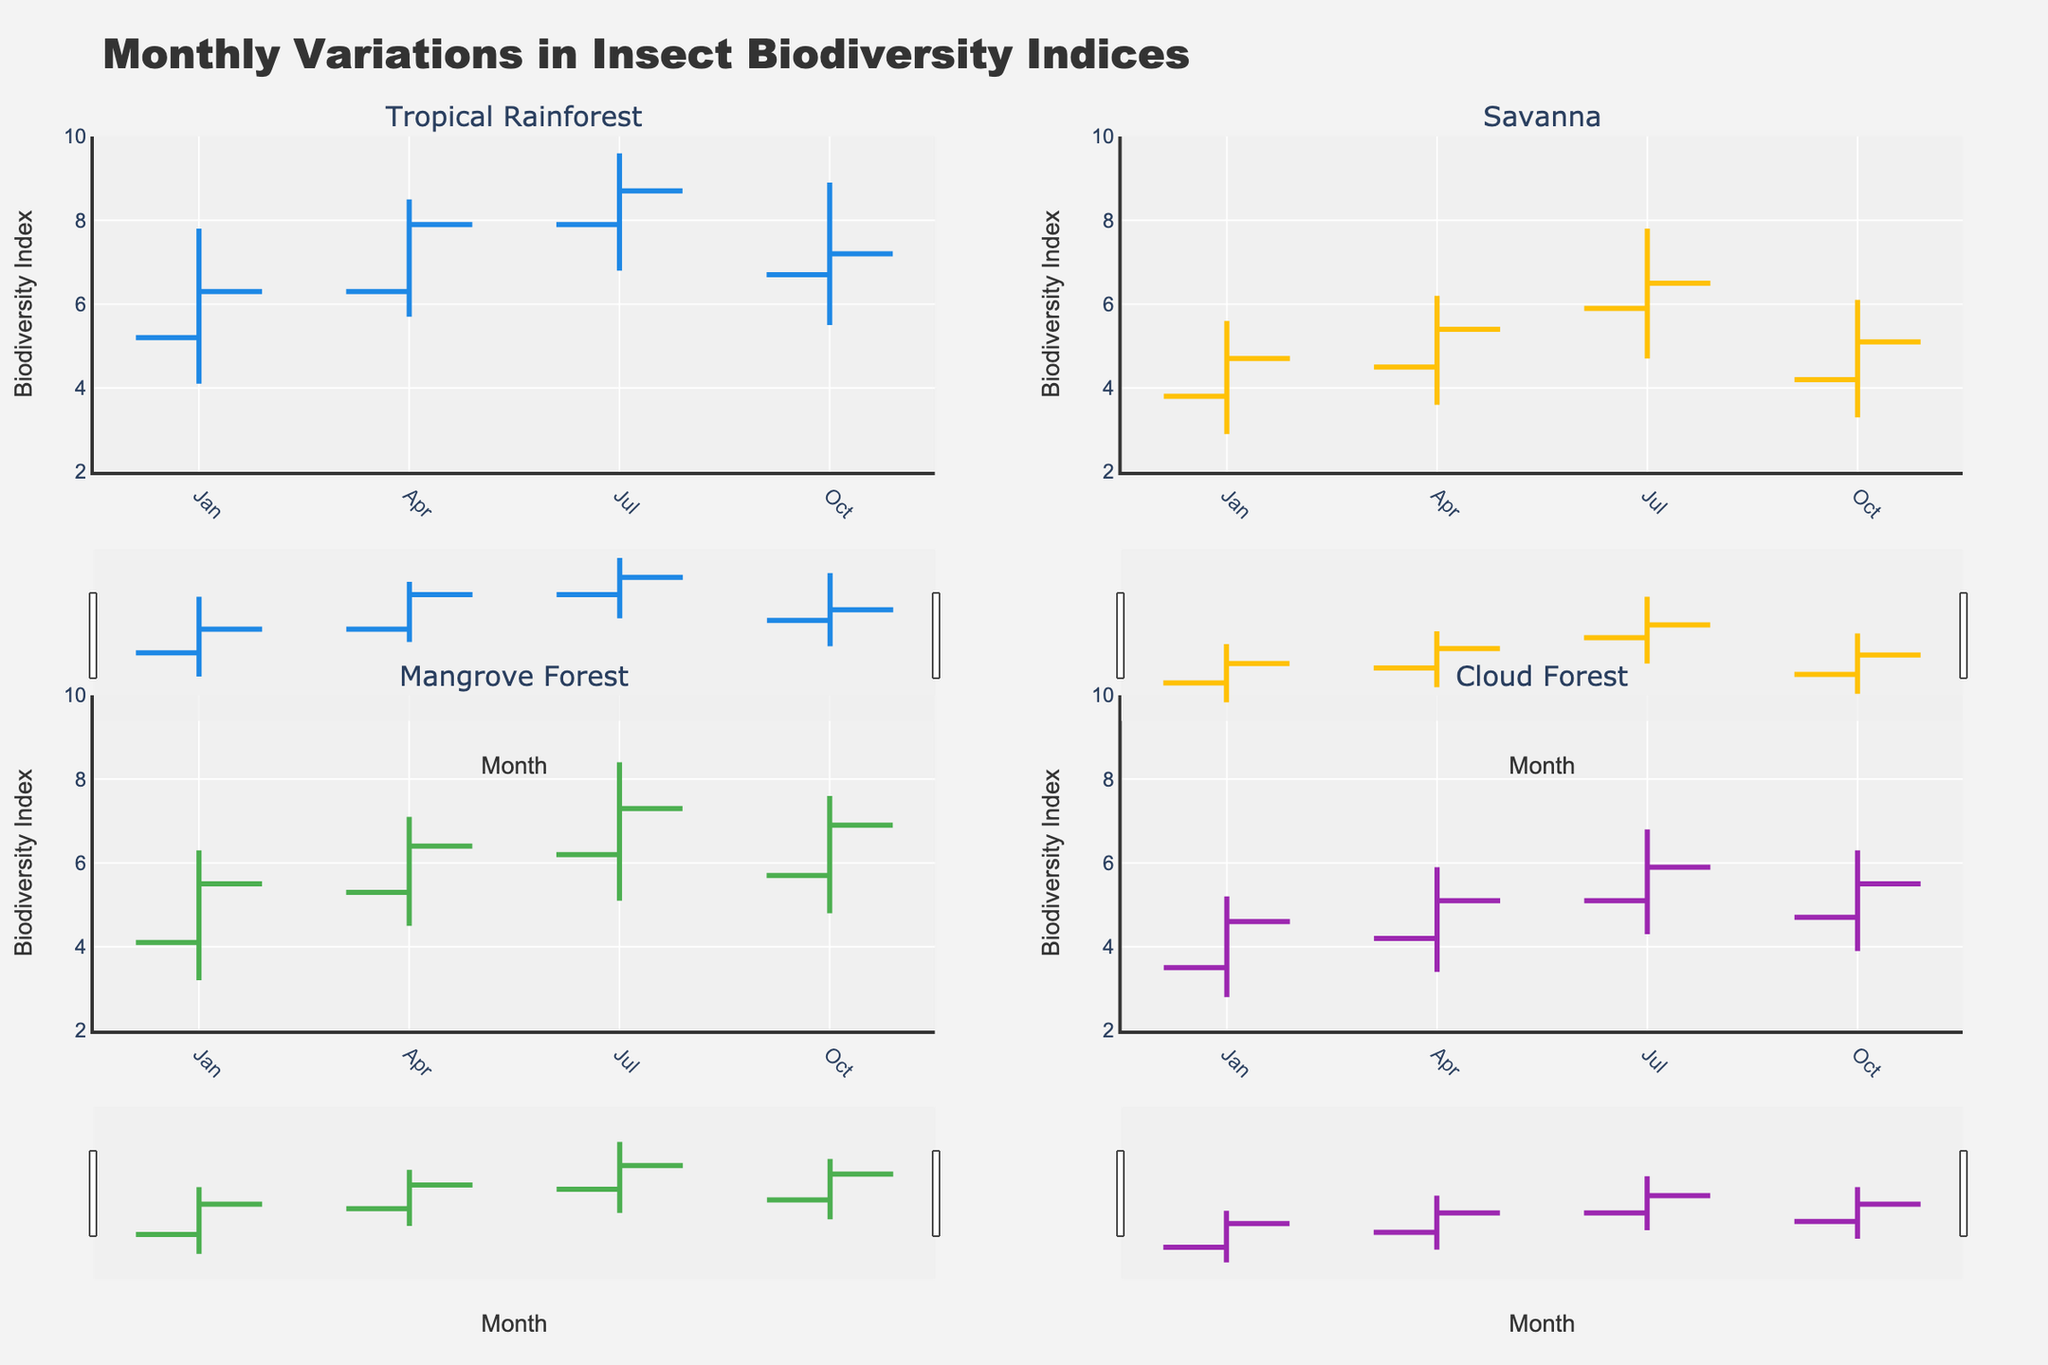Which ecosystem has the highest observed biodiversity index in July? We look at the 'High' values for July in each ecosystem. The highest 'High' value in July is 9.6 in the Tropical Rainforest.
Answer: Tropical Rainforest Which ecosystem shows the lowest biodiversity index in January? We examine the 'Low' values for January across ecosystems. The lowest 'Low' value in January is 2.8 in the Cloud Forest.
Answer: Cloud Forest What is the difference between the highest and lowest biodiversity indices observed in the Savanna in October? Find the 'High' value (6.1) and the 'Low' value (3.3) for the Savanna in October. The difference is 6.1 - 3.3 = 2.8.
Answer: 2.8 How did the biodiversity index in the Mangrove Forest change from April to July? We compare the 'Close' values: April (6.4) and July (7.3). The biodiversity index increased by 7.3 - 6.4 = 0.9.
Answer: Increased by 0.9 Which month has the highest closing biodiversity index in the Tropical Rainforest? We check 'Close' values for each month in the Tropical Rainforest: Jan (6.3), Apr (7.9), Jul (8.7), Oct (7.2). July has the highest close value of 8.7.
Answer: July What is the average closing biodiversity index for the Cloud Forest across all months? Sum the 'Close' values for Cloud Forest (4.6 + 5.1 + 5.9 + 5.5) = 21.1, then divide by 4. The average is 21.1 / 4 = 5.275.
Answer: 5.275 Which ecosystem shows the most consistent biodiversity indices, with the smallest range between 'High' and 'Low' values in April? Calculate the ranges for April: Tropical Rainforest (8.5-5.7=2.8), Savanna (6.2-3.6=2.6), Mangrove Forest (7.1-4.5=2.6), Cloud Forest (5.9-3.4=2.5). Cloud Forest has the smallest range.
Answer: Cloud Forest 